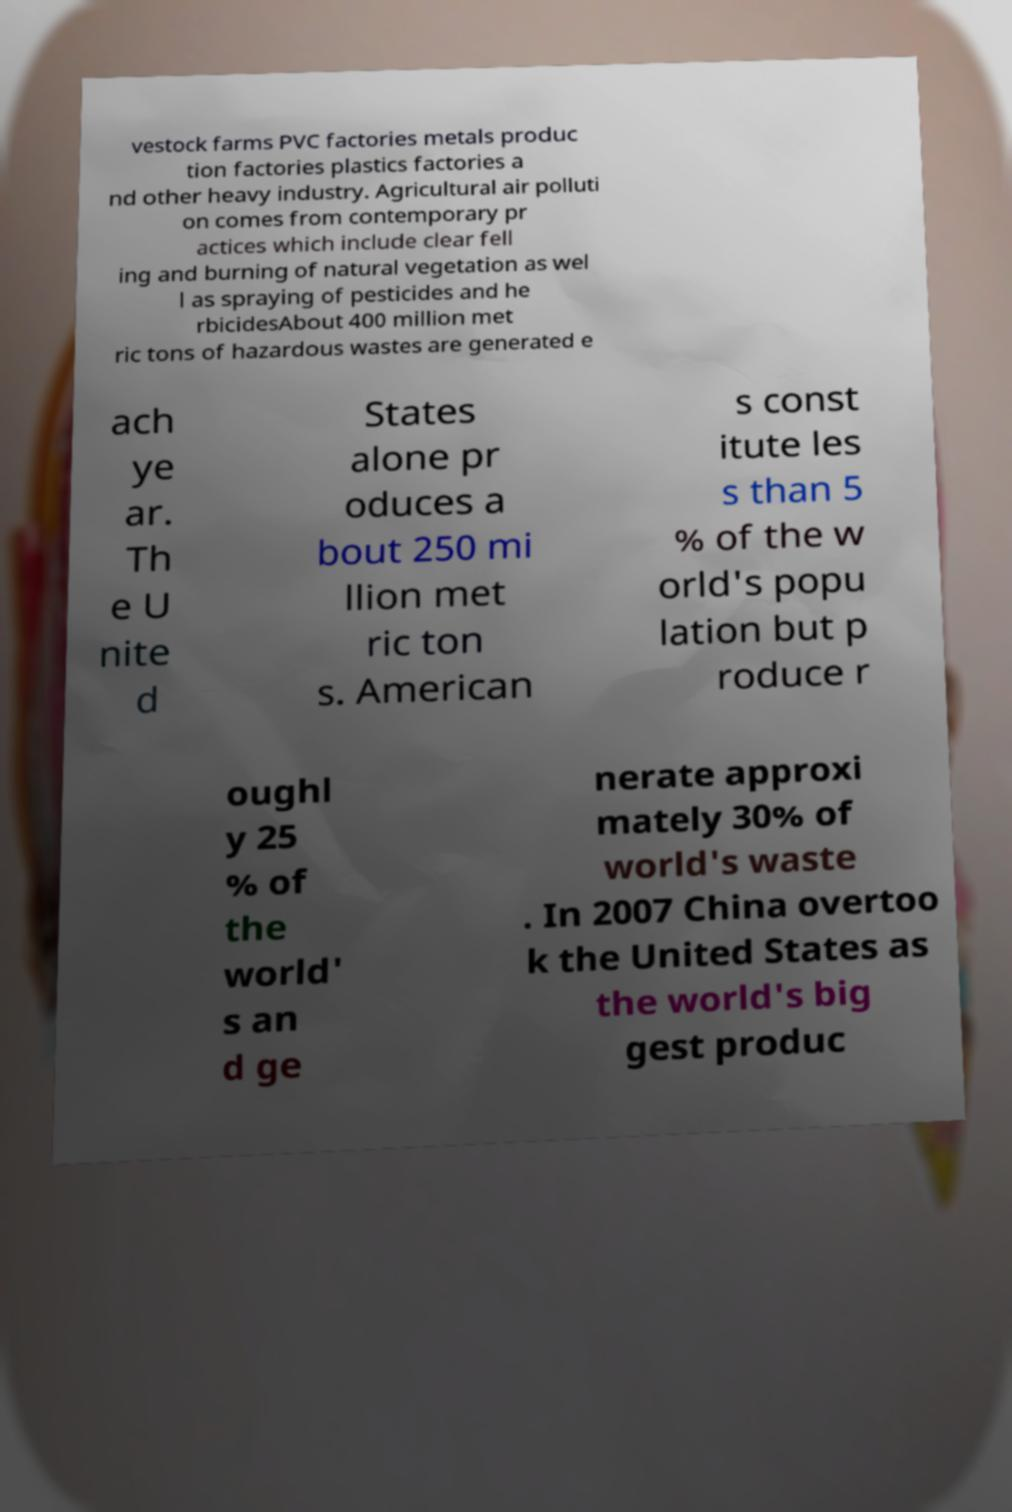I need the written content from this picture converted into text. Can you do that? vestock farms PVC factories metals produc tion factories plastics factories a nd other heavy industry. Agricultural air polluti on comes from contemporary pr actices which include clear fell ing and burning of natural vegetation as wel l as spraying of pesticides and he rbicidesAbout 400 million met ric tons of hazardous wastes are generated e ach ye ar. Th e U nite d States alone pr oduces a bout 250 mi llion met ric ton s. American s const itute les s than 5 % of the w orld's popu lation but p roduce r oughl y 25 % of the world' s an d ge nerate approxi mately 30% of world's waste . In 2007 China overtoo k the United States as the world's big gest produc 